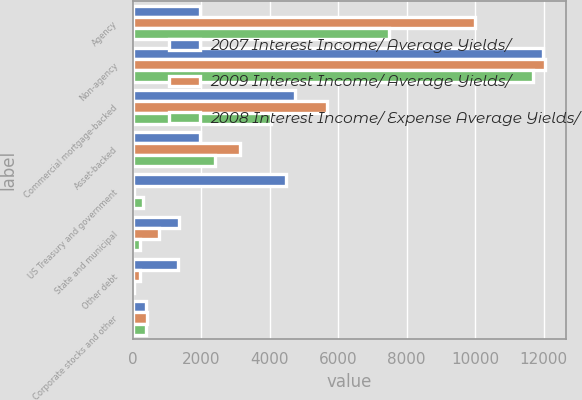Convert chart. <chart><loc_0><loc_0><loc_500><loc_500><stacked_bar_chart><ecel><fcel>Agency<fcel>Non-agency<fcel>Commercial mortgage-backed<fcel>Asset-backed<fcel>US Treasury and government<fcel>State and municipal<fcel>Other debt<fcel>Corporate stocks and other<nl><fcel>2007 Interest Income/ Average Yields/<fcel>1963<fcel>11993<fcel>4748<fcel>1963<fcel>4477<fcel>1354<fcel>1327<fcel>398<nl><fcel>2009 Interest Income/ Average Yields/<fcel>10003<fcel>12055<fcel>5666<fcel>3126<fcel>50<fcel>764<fcel>220<fcel>412<nl><fcel>2008 Interest Income/ Expense Average Yields/<fcel>7481<fcel>11682<fcel>4025<fcel>2394<fcel>293<fcel>227<fcel>47<fcel>392<nl></chart> 